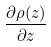<formula> <loc_0><loc_0><loc_500><loc_500>\frac { \partial \rho ( z ) } { \partial z }</formula> 